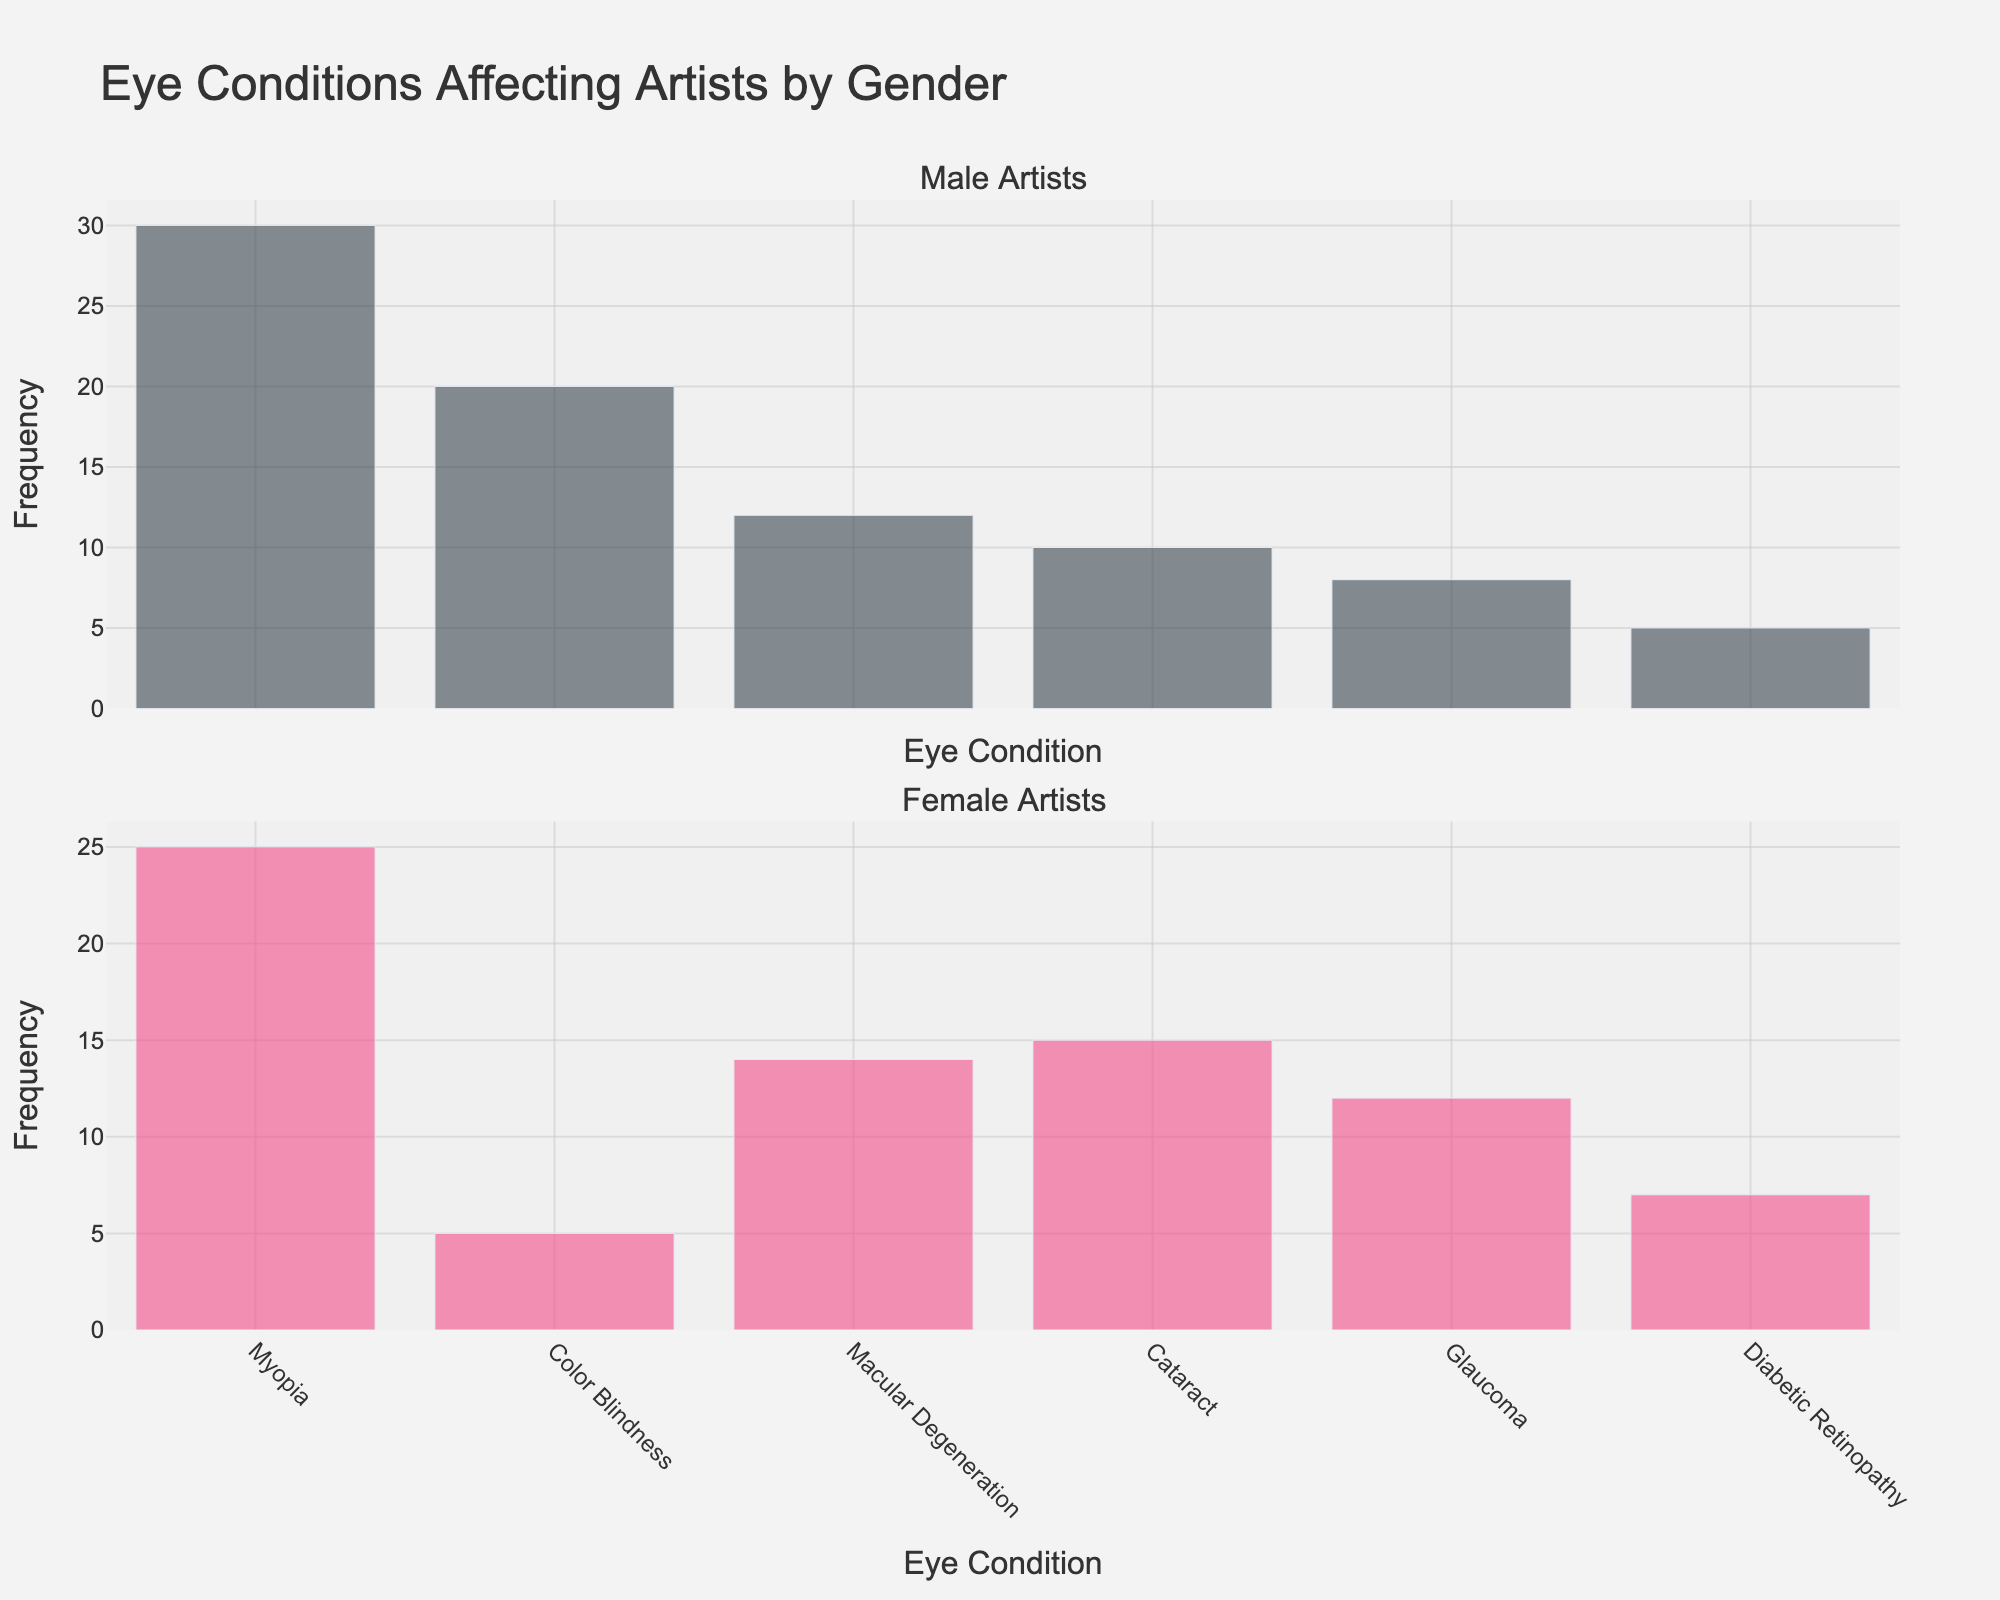What is the most common eye condition among male artists? The most common eye condition can be determined by looking at the highest bar in the "Male Artists" subplot. The condition with the highest frequency is Myopia with a value of 30.
Answer: Myopia What is the least common eye condition among female artists? The least common eye condition can be identified by finding the shortest bar in the "Female Artists" subplot. The condition with the lowest frequency is Color Blindness with a value of 5.
Answer: Color Blindness What is the total frequency of Myopia cases for both genders? The total frequency of Myopia cases can be calculated by adding the frequencies from the Male and Female subplots. For males, it is 30, and for females, it is 25. Total is 30 + 25 = 55.
Answer: 55 How does the frequency of Cataract cases compare between male and female artists? Comparing the heights of the bars for Cataract in both subplots, the frequency for males is 10 and for females is 15. Therefore, female artists have a higher occurrence of Cataract than male artists.
Answer: Female artists have a higher frequency Which gender has a higher total frequency of eye conditions? The total frequency for each gender can be calculated by summing up all the frequencies in their respective subplots. For males: 20 + 30 + 10 + 8 + 5 + 12 = 85. For females: 5 + 25 + 15 + 12 + 7 + 14 = 78.
Answer: Males Is there any eye condition with equal frequency for both genders? By inspecting the bars in both subplots, we can compare the frequencies. There is no eye condition with exactly equal frequencies for both genders.
Answer: No What is the average frequency of eye conditions for female artists? The average can be calculated by summing up the frequencies and dividing by the number of conditions. The total frequency for females is 78, and there are 6 conditions. Average is 78 / 6 = 13.
Answer: 13 How much higher is the frequency of Color Blindness in male artists compared to female artists? The frequency of Color Blindness in male artists is 20 and in female artists is 5. The difference is 20 - 5 = 15.
Answer: 15 What is the ratio of Myopia cases between male and female artists? The ratio can be determined by dividing the frequency for males by the frequency for females. For Myopia, the ratio is 30 / 25 = 1.2.
Answer: 1.2 Which condition has the smallest difference in frequency between male and female artists? To find this, calculate the absolute differences for each condition between males and females. The smallest difference is found for Glaucoma:
Answer: Glaucoma (4) 